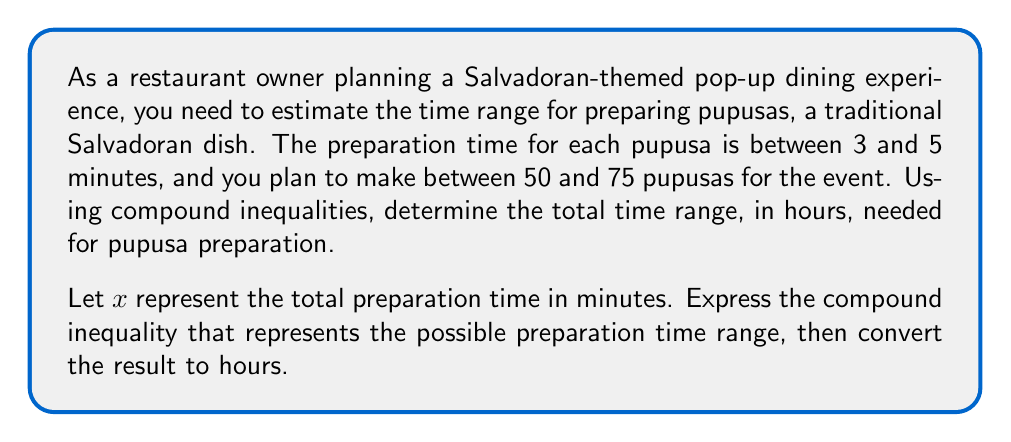Help me with this question. Let's approach this step-by-step:

1) First, let's establish our variables:
   - Let $t$ be the time to prepare one pupusa (in minutes)
   - Let $n$ be the number of pupusas to be prepared
   - Let $x$ be the total preparation time (in minutes)

2) We're given these inequalities:
   $3 \leq t \leq 5$ (time per pupusa)
   $50 \leq n \leq 75$ (number of pupusas)

3) The total preparation time $x$ is the product of $t$ and $n$. To find the minimum and maximum values of $x$, we multiply the minimum and maximum values of $t$ and $n$:

   Minimum time: $3 \times 50 = 150$ minutes
   Maximum time: $5 \times 75 = 375$ minutes

4) Therefore, our compound inequality for $x$ in minutes is:

   $150 \leq x \leq 375$

5) To convert this to hours, we divide both sides by 60:

   $\frac{150}{60} \leq \frac{x}{60} \leq \frac{375}{60}$

6) Simplifying:

   $2.5 \leq \frac{x}{60} \leq 6.25$

This gives us the final compound inequality in hours.
Answer: $2.5 \leq \frac{x}{60} \leq 6.25$, where $x$ is the total preparation time in minutes and $\frac{x}{60}$ is the time in hours. The preparation time range is between 2.5 and 6.25 hours. 